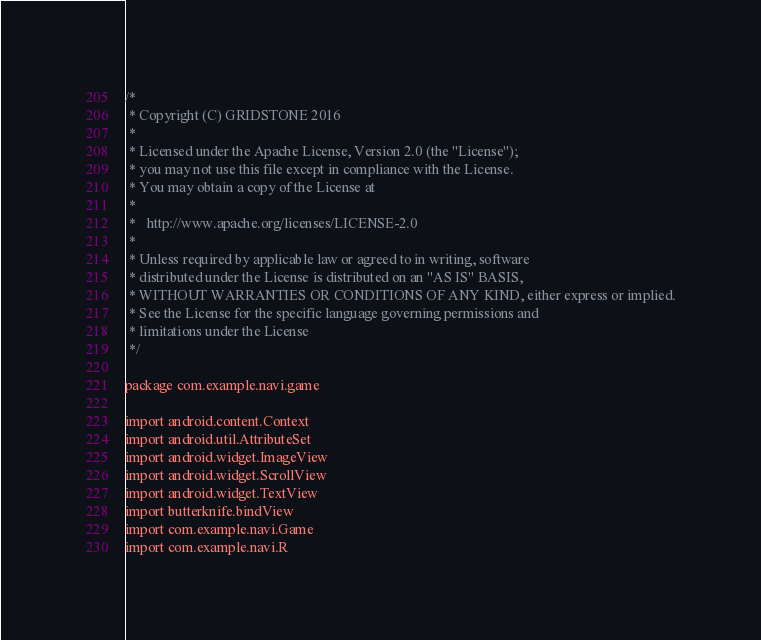Convert code to text. <code><loc_0><loc_0><loc_500><loc_500><_Kotlin_>/*
 * Copyright (C) GRIDSTONE 2016
 *
 * Licensed under the Apache License, Version 2.0 (the "License");
 * you may not use this file except in compliance with the License.
 * You may obtain a copy of the License at
 *
 *   http://www.apache.org/licenses/LICENSE-2.0
 *
 * Unless required by applicable law or agreed to in writing, software
 * distributed under the License is distributed on an "AS IS" BASIS,
 * WITHOUT WARRANTIES OR CONDITIONS OF ANY KIND, either express or implied.
 * See the License for the specific language governing permissions and
 * limitations under the License
 */

package com.example.navi.game

import android.content.Context
import android.util.AttributeSet
import android.widget.ImageView
import android.widget.ScrollView
import android.widget.TextView
import butterknife.bindView
import com.example.navi.Game
import com.example.navi.R</code> 